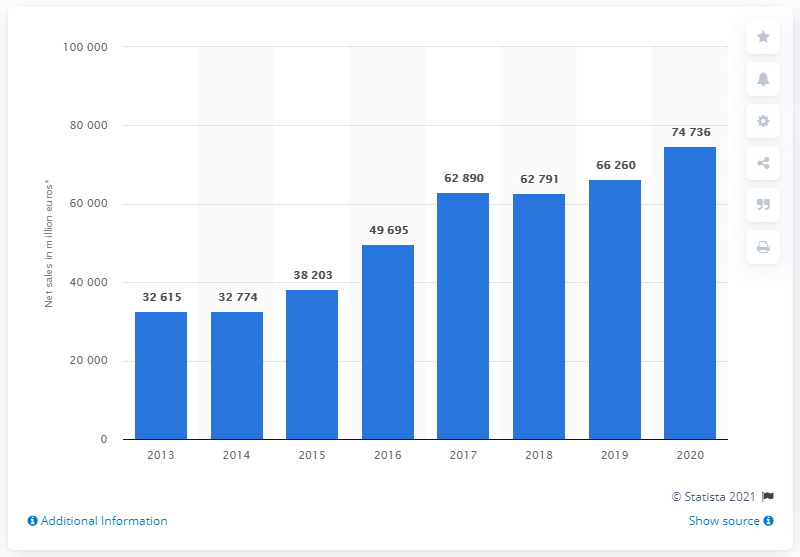Highlight a few significant elements in this photo. Ahold Delhaize's net sales in 2018 were approximately 62,791. Ahold Delhaize's global net sales in 2020 were approximately 74,736. 